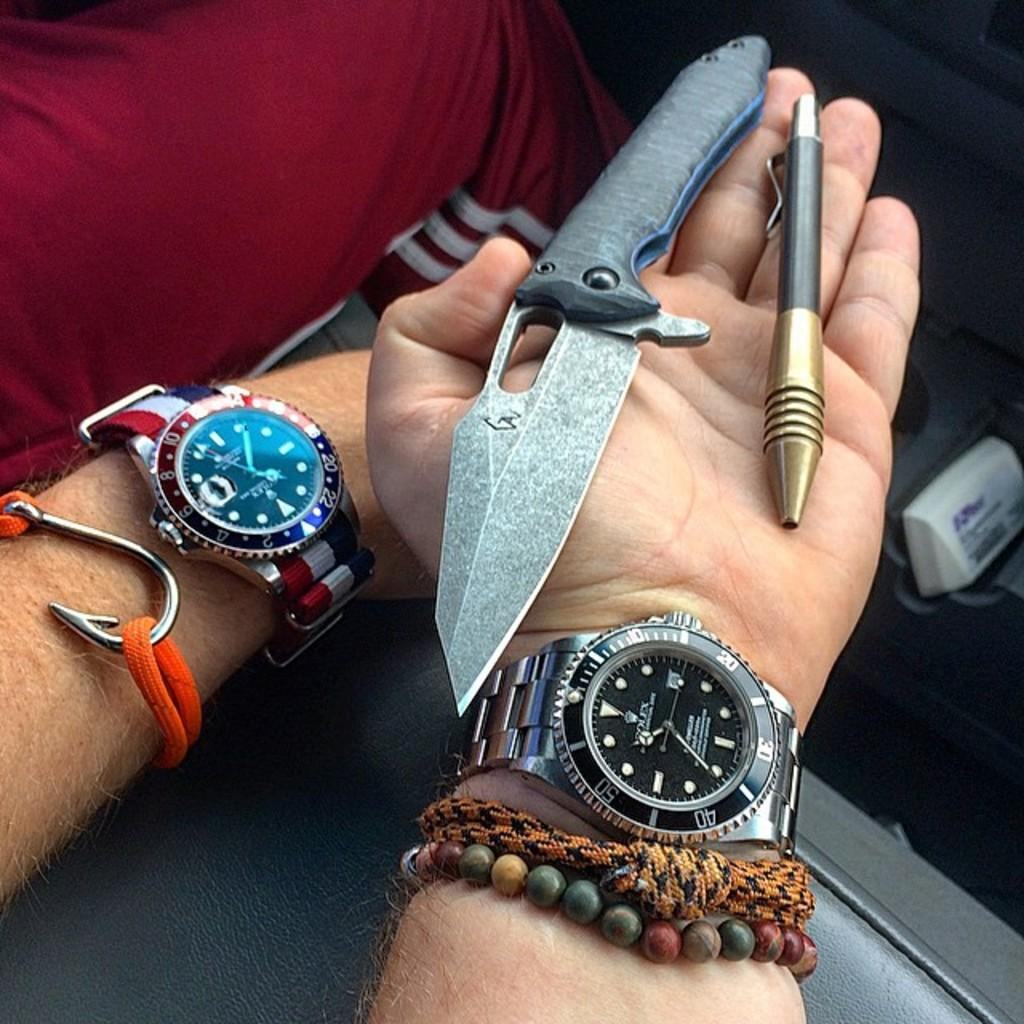<image>
Summarize the visual content of the image. A hand holding a knife and a pen and wearing a watch with the number 50 on it. 